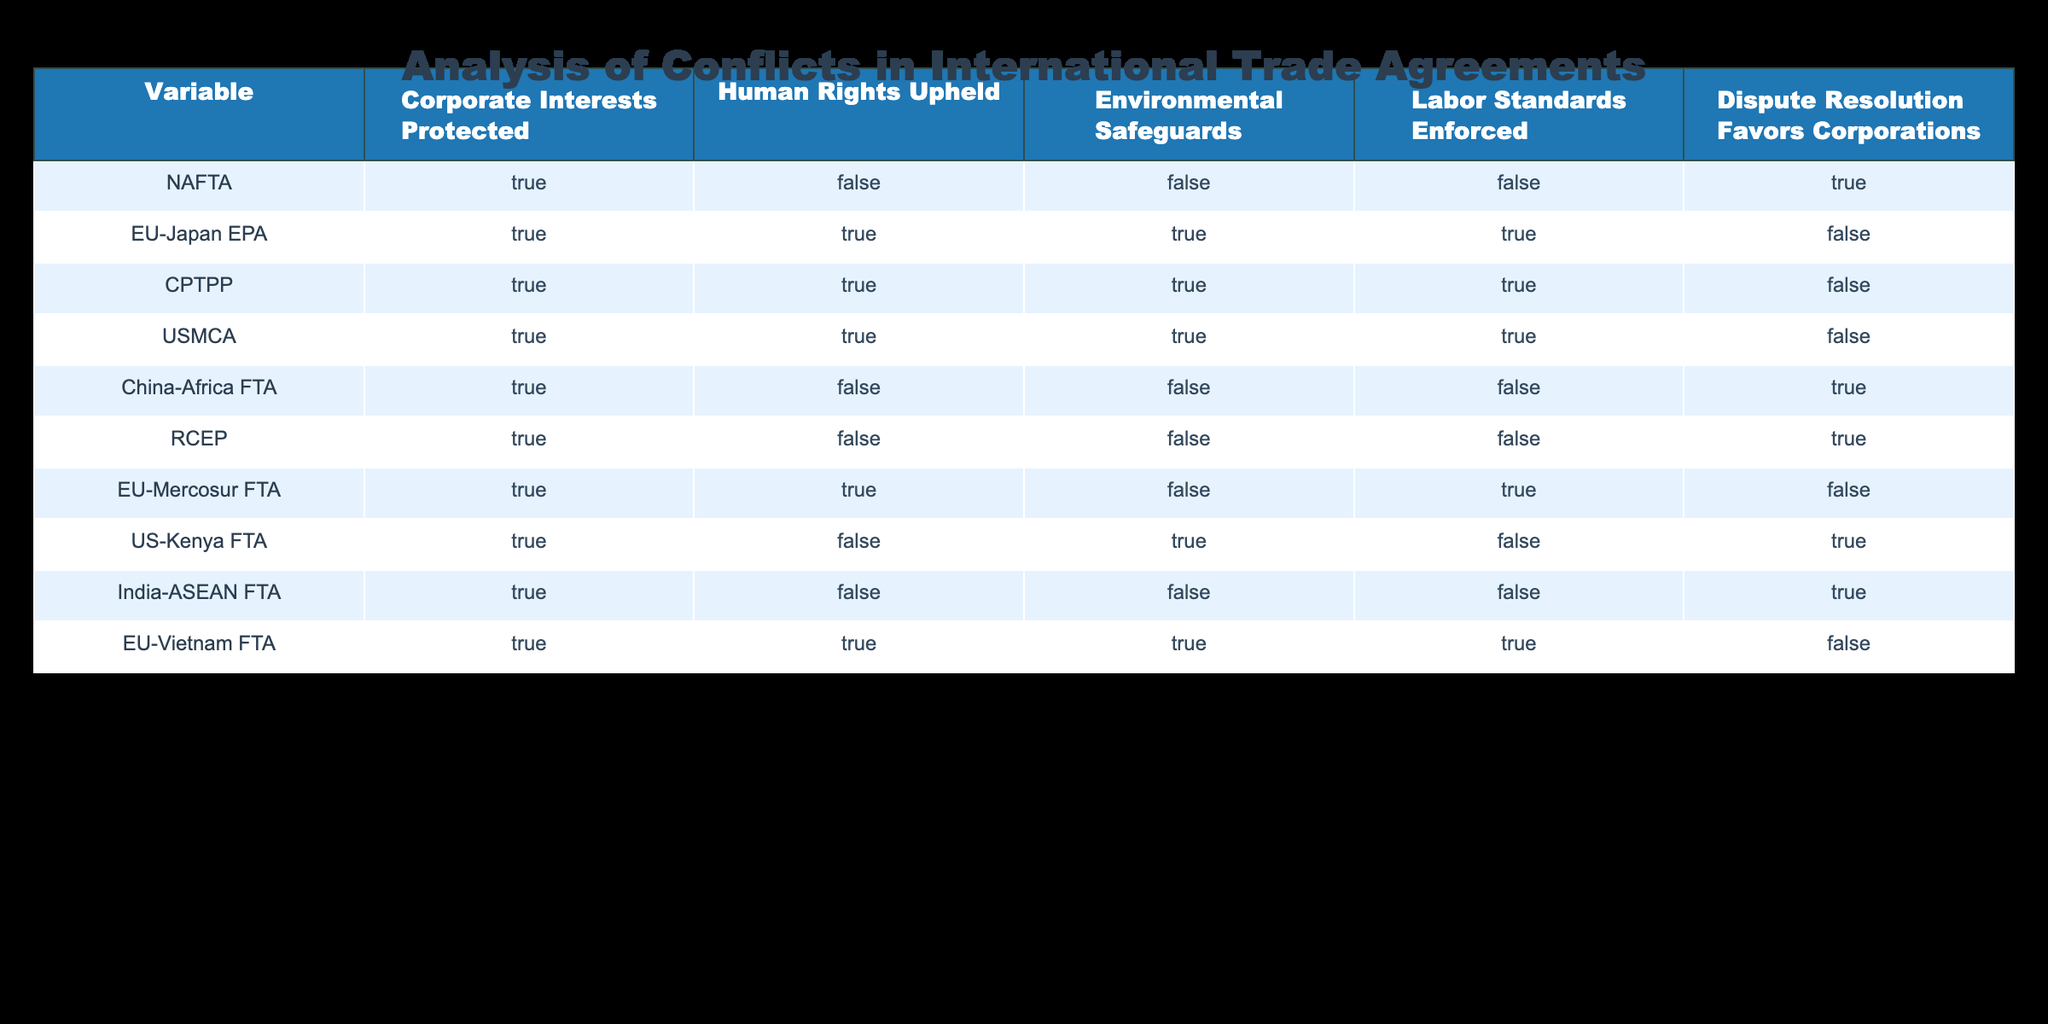What are the trade agreements where human rights are upheld? By examining the "Human Rights Upheld" column, we look for rows marked as TRUE. The agreements are: EU-Japan EPA, CPTPP, USMCA, EU-Mercosur FTA, and EU-Vietnam FTA.
Answer: EU-Japan EPA, CPTPP, USMCA, EU-Mercosur FTA, EU-Vietnam FTA Which trade agreements have labor standards enforced? We refer to the "Labor Standards Enforced" column and check for TRUE values. The agreements with enforced labor standards are: EU-Japan EPA, CPTPP, USMCA, EU-Mercosur FTA, and EU-Vietnam FTA.
Answer: EU-Japan EPA, CPTPP, USMCA, EU-Mercosur FTA, EU-Vietnam FTA Does the US-Kenya FTA protect corporate interests? Looking at the "Corporate Interests Protected" column, we find TRUE for the US-Kenya FTA, indicating that corporate interests are indeed protected.
Answer: Yes Are there any trade agreements that uphold human rights while also enforcing labor standards? We must find agreements that have TRUE in both "Human Rights Upheld" and "Labor Standards Enforced". Upon reviewing the table, the agreements meeting both conditions are: EU-Japan EPA, CPTPP, and USMCA.
Answer: EU-Japan EPA, CPTPP, USMCA What is the total number of trade agreements that favor corporations in dispute resolution? We check the "Dispute Resolution Favors Corporations" column for TRUE values. There are 6 agreements that favor corporations: NAFTA, China-Africa FTA, RCEP, US-Kenya FTA, and others. Thus, we count these entries to find the total is 6.
Answer: 6 Does any trade agreement provide environmental safeguards? We look at the "Environmental Safeguards" column to identify TRUE values. The agreements that provide environmental safeguards are: EU-Japan EPA, CPTPP, USMCA, EU-Vietnam FTA, and EU-Mercosur FTA.
Answer: Yes Which trade agreements do not uphold human rights and protect corporate interests? We evaluate the conditions where "Corporate Interests Protected" is TRUE and "Human Rights Upheld" is FALSE. The agreements fitting this criteria are NAFTA, China-Africa FTA, RCEP, and India-ASEAN FTA.
Answer: NAFTA, China-Africa FTA, RCEP, India-ASEAN FTA How many agreements have both environmental safeguards and enforce labor standards? We identify agreements in both the "Environmental Safeguards" and "Labor Standards Enforced" columns that are TRUE. The agreements fitting this criteria are EU-Japan EPA, CPTPP, and USMCA. Therefore, the count is 3.
Answer: 3 Is there any trade agreement that does not protect corporate interests? Checking the "Corporate Interests Protected" column, all listed agreements have this marked as TRUE, which implies that there are no agreements that do not protect corporate interests.
Answer: No 